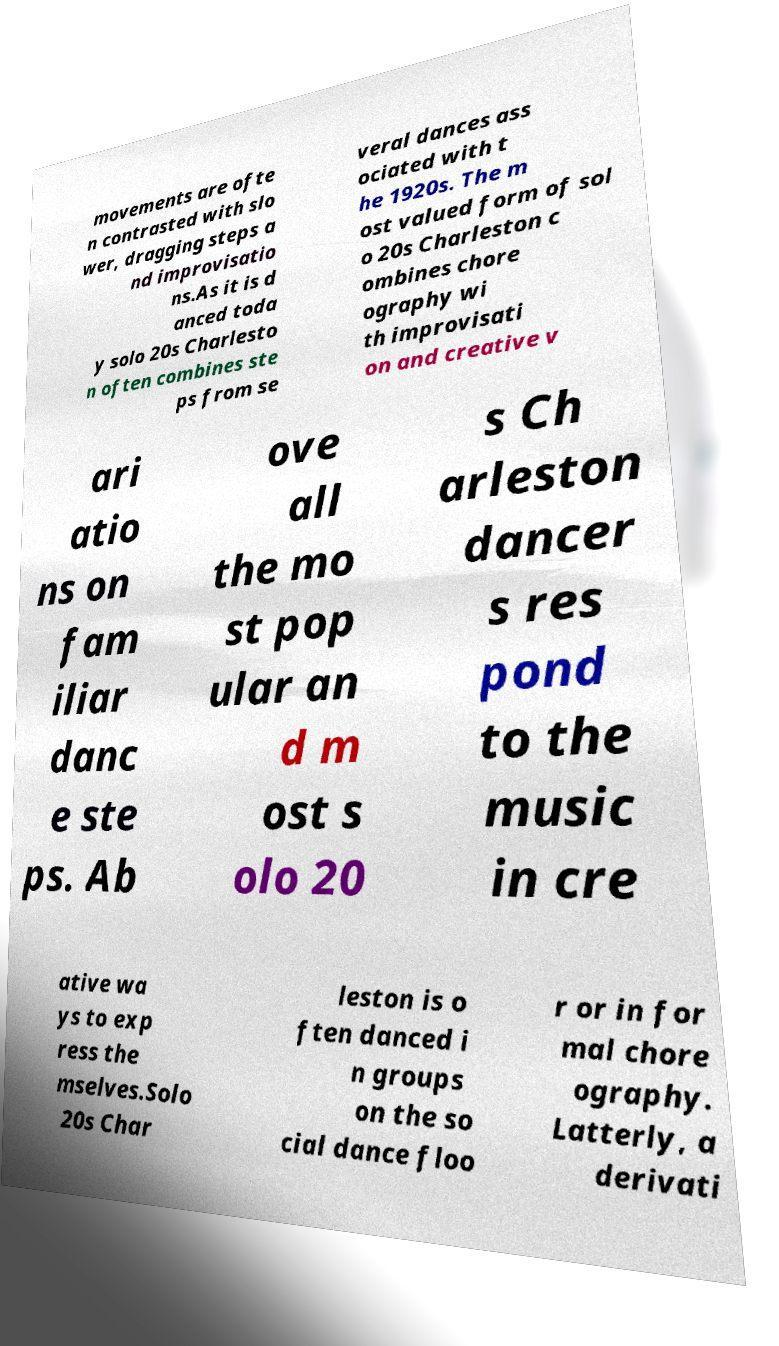For documentation purposes, I need the text within this image transcribed. Could you provide that? movements are ofte n contrasted with slo wer, dragging steps a nd improvisatio ns.As it is d anced toda y solo 20s Charlesto n often combines ste ps from se veral dances ass ociated with t he 1920s. The m ost valued form of sol o 20s Charleston c ombines chore ography wi th improvisati on and creative v ari atio ns on fam iliar danc e ste ps. Ab ove all the mo st pop ular an d m ost s olo 20 s Ch arleston dancer s res pond to the music in cre ative wa ys to exp ress the mselves.Solo 20s Char leston is o ften danced i n groups on the so cial dance floo r or in for mal chore ography. Latterly, a derivati 